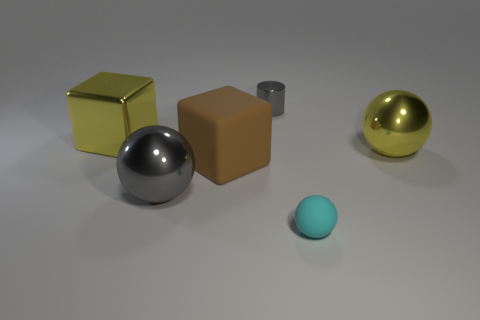Subtract all big metal balls. How many balls are left? 1 Add 3 large gray metal cylinders. How many objects exist? 9 Subtract all cubes. How many objects are left? 4 Add 6 tiny gray cylinders. How many tiny gray cylinders are left? 7 Add 5 rubber balls. How many rubber balls exist? 6 Subtract 1 yellow blocks. How many objects are left? 5 Subtract all big yellow cylinders. Subtract all small matte spheres. How many objects are left? 5 